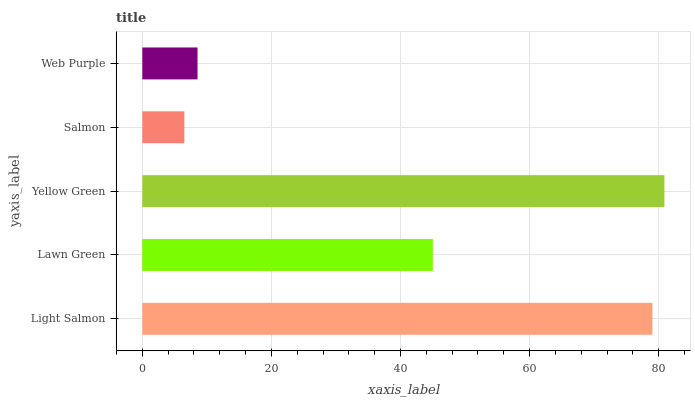Is Salmon the minimum?
Answer yes or no. Yes. Is Yellow Green the maximum?
Answer yes or no. Yes. Is Lawn Green the minimum?
Answer yes or no. No. Is Lawn Green the maximum?
Answer yes or no. No. Is Light Salmon greater than Lawn Green?
Answer yes or no. Yes. Is Lawn Green less than Light Salmon?
Answer yes or no. Yes. Is Lawn Green greater than Light Salmon?
Answer yes or no. No. Is Light Salmon less than Lawn Green?
Answer yes or no. No. Is Lawn Green the high median?
Answer yes or no. Yes. Is Lawn Green the low median?
Answer yes or no. Yes. Is Yellow Green the high median?
Answer yes or no. No. Is Light Salmon the low median?
Answer yes or no. No. 